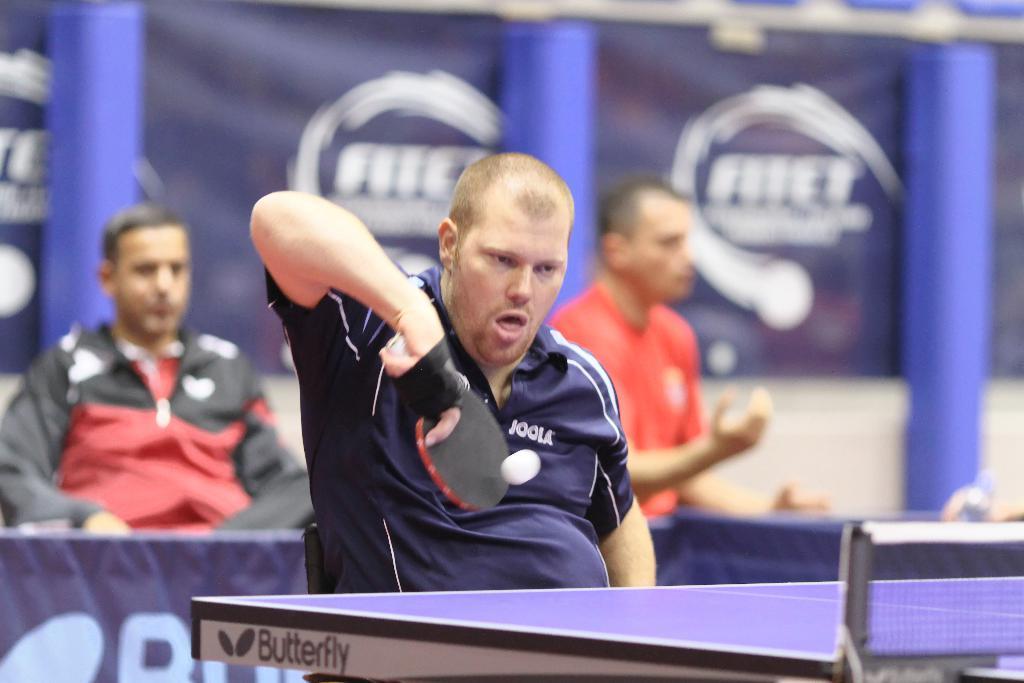How would you summarize this image in a sentence or two? in this picture we can see a man is sitting on the chair, and he is holding a racket in his hand and playing with the ball, and in front there is the board and net on it ,and at back side there are people sitting on the chair. 